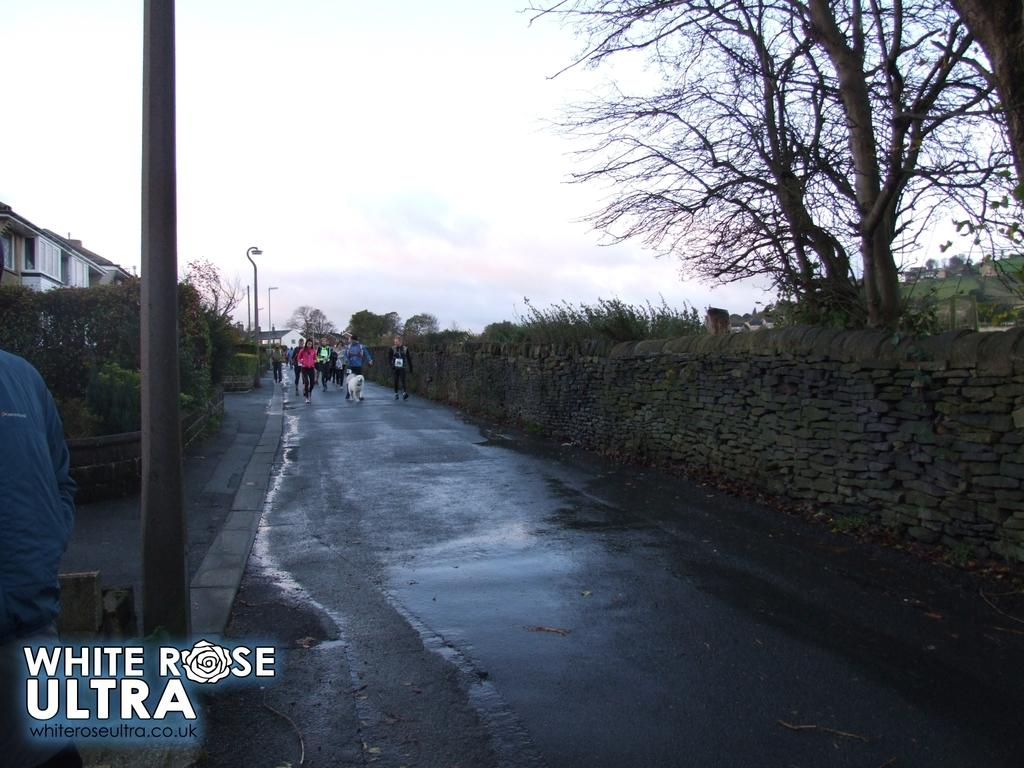<image>
Render a clear and concise summary of the photo. Group of people walking down a road and the words "White Rose Ultra" under them. 